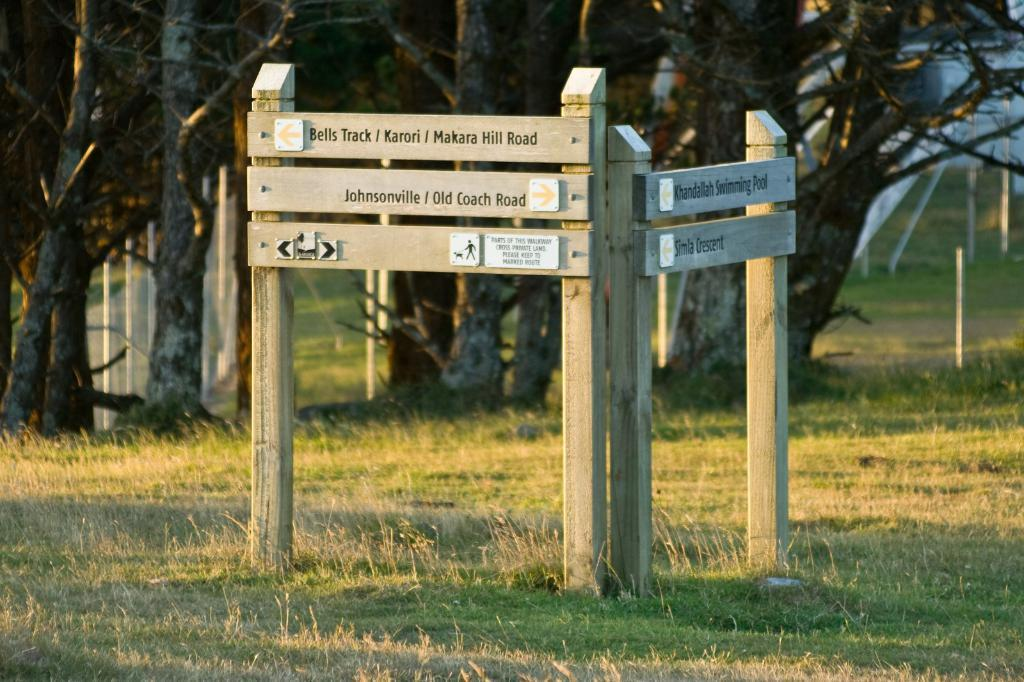What is the main object in the image with writing on it? There is a wooden object with writing on it in the image. How is the wooden object positioned in the image? The wooden object is attached to a stand. What type of environment is depicted in the image? The ground is covered in greenery, and there are trees in the background of the image. What type of cloud is visible in the image? There is no cloud visible in the image; it only features a wooden object with writing, a stand, greenery on the ground, and trees in the background. 